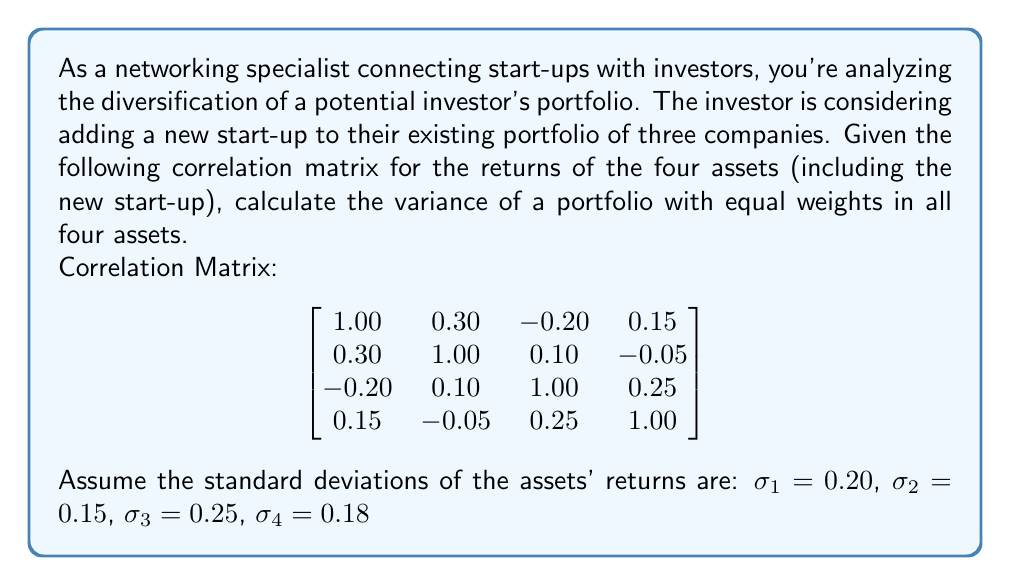Can you answer this question? To solve this problem, we'll follow these steps:

1) First, recall the formula for portfolio variance with multiple assets:

   $$\sigma_p^2 = \sum_{i=1}^n \sum_{j=1}^n w_i w_j \sigma_i \sigma_j \rho_{ij}$$

   Where:
   - $\sigma_p^2$ is the portfolio variance
   - $w_i$ and $w_j$ are the weights of assets i and j
   - $\sigma_i$ and $\sigma_j$ are the standard deviations of assets i and j
   - $\rho_{ij}$ is the correlation coefficient between assets i and j

2) We're given equal weights for all assets, so $w_1 = w_2 = w_3 = w_4 = 0.25$

3) We need to calculate the covariance matrix. The formula for covariance is:

   $$\sigma_{ij} = \rho_{ij} \sigma_i \sigma_j$$

4) Let's calculate each element of the covariance matrix:

   $$\begin{bmatrix}
   (0.20)^2 & 0.30(0.20)(0.15) & -0.20(0.20)(0.25) & 0.15(0.20)(0.18) \\
   0.30(0.20)(0.15) & (0.15)^2 & 0.10(0.15)(0.25) & -0.05(0.15)(0.18) \\
   -0.20(0.20)(0.25) & 0.10(0.15)(0.25) & (0.25)^2 & 0.25(0.25)(0.18) \\
   0.15(0.20)(0.18) & -0.05(0.15)(0.18) & 0.25(0.25)(0.18) & (0.18)^2
   \end{bmatrix}$$

   $$\begin{bmatrix}
   0.0400 & 0.0090 & -0.0100 & 0.0054 \\
   0.0090 & 0.0225 & 0.0038 & -0.0014 \\
   -0.0100 & 0.0038 & 0.0625 & 0.0113 \\
   0.0054 & -0.0014 & 0.0113 & 0.0324
   \end{bmatrix}$$

5) Now, we can calculate the portfolio variance:

   $$\sigma_p^2 = \sum_{i=1}^4 \sum_{j=1}^4 (0.25)(0.25)\sigma_{ij}$$

   $$\sigma_p^2 = 0.0625 (0.0400 + 0.0090 - 0.0100 + 0.0054 + 0.0090 + 0.0225 + 0.0038 - 0.0014 - 0.0100 + 0.0038 + 0.0625 + 0.0113 + 0.0054 - 0.0014 + 0.0113 + 0.0324)$$

   $$\sigma_p^2 = 0.0625 (0.1926)$$

   $$\sigma_p^2 = 0.0120375$$
Answer: The variance of the equally-weighted portfolio is approximately 0.0120 or 1.20%. 